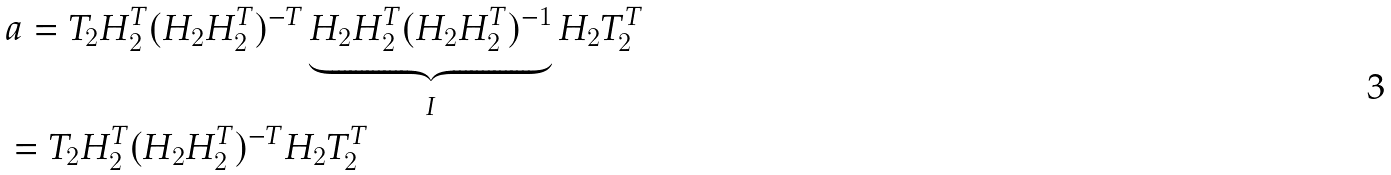Convert formula to latex. <formula><loc_0><loc_0><loc_500><loc_500>& a = T _ { 2 } H _ { 2 } ^ { T } ( H _ { 2 } H _ { 2 } ^ { T } ) ^ { - T } \underbrace { H _ { 2 } H _ { 2 } ^ { T } ( H _ { 2 } H _ { 2 } ^ { T } ) ^ { - 1 } } _ { I } H _ { 2 } T _ { 2 } ^ { T } \\ & = T _ { 2 } H _ { 2 } ^ { T } ( H _ { 2 } H _ { 2 } ^ { T } ) ^ { - T } H _ { 2 } T _ { 2 } ^ { T }</formula> 